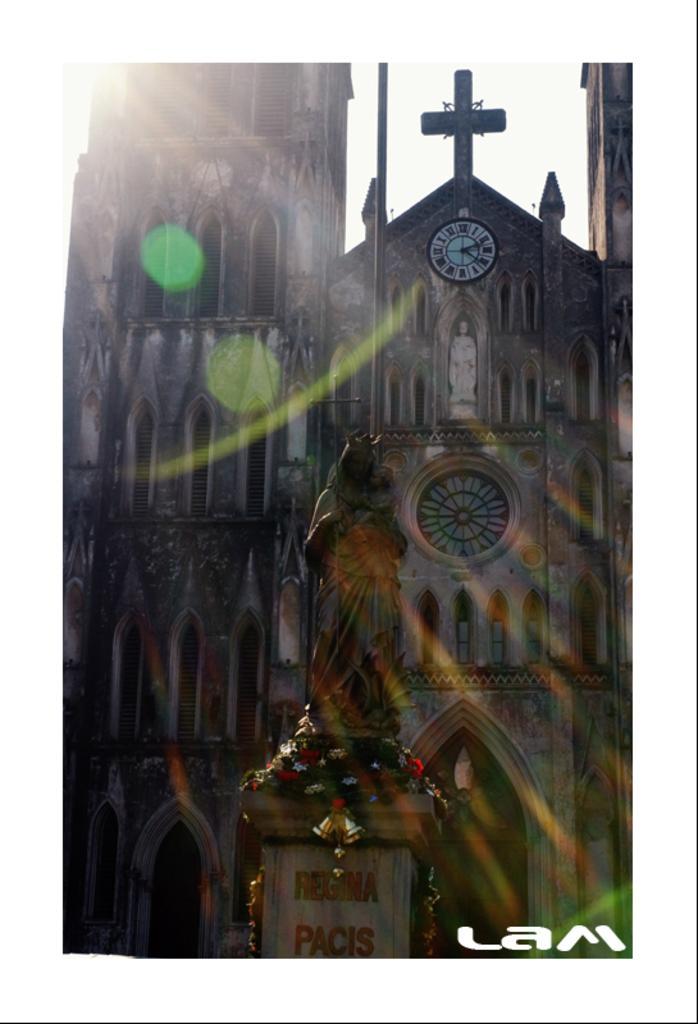Please provide a concise description of this image. In this image I can see a sculpture, few decorations, a building, a clock and here I can see something is written. 